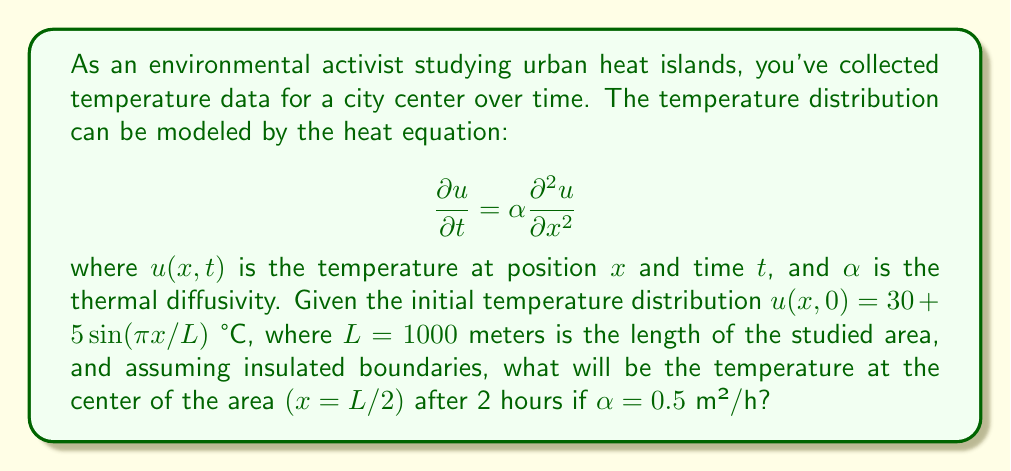Provide a solution to this math problem. To solve this problem, we need to use the solution to the heat equation with insulated boundaries:

1) The general solution is given by:
   $$u(x,t) = A_0 + \sum_{n=1}^{\infty} A_n \cos(\frac{n\pi x}{L}) e^{-\alpha (\frac{n\pi}{L})^2 t}$$

2) The initial condition is $u(x,0) = 30 + 5\sin(\pi x/L)$
   We can rewrite this as: $u(x,0) = 30 + 5\cos(\pi x/L - \pi/2)$

3) Comparing with the general solution, we see that:
   $A_0 = 30$
   $A_1 = 5$ (for $n=1$)
   $A_n = 0$ for $n > 1$

4) Therefore, our specific solution is:
   $$u(x,t) = 30 + 5\cos(\frac{\pi x}{L} - \frac{\pi}{2}) e^{-\alpha (\frac{\pi}{L})^2 t}$$

5) At the center, $x = L/2 = 500$ m. After 2 hours, $t = 2$ h.

6) Substituting these values:
   $$u(500,2) = 30 + 5\cos(\frac{\pi \cdot 500}{1000} - \frac{\pi}{2}) e^{-0.5 (\frac{\pi}{1000})^2 \cdot 2}$$

7) Simplify:
   $$u(500,2) = 30 + 5\cos(\frac{\pi}{2} - \frac{\pi}{2}) e^{-0.5 (\frac{\pi}{1000})^2 \cdot 2}$$
   $$= 30 + 5\cos(0) e^{-\frac{\pi^2}{10^6}}$$
   $$= 30 + 5 e^{-\frac{\pi^2}{10^6}}$$

8) Calculate:
   $$= 30 + 5 \cdot 0.9999 = 34.9995 \approx 35.00°C$$
Answer: 35.00°C 